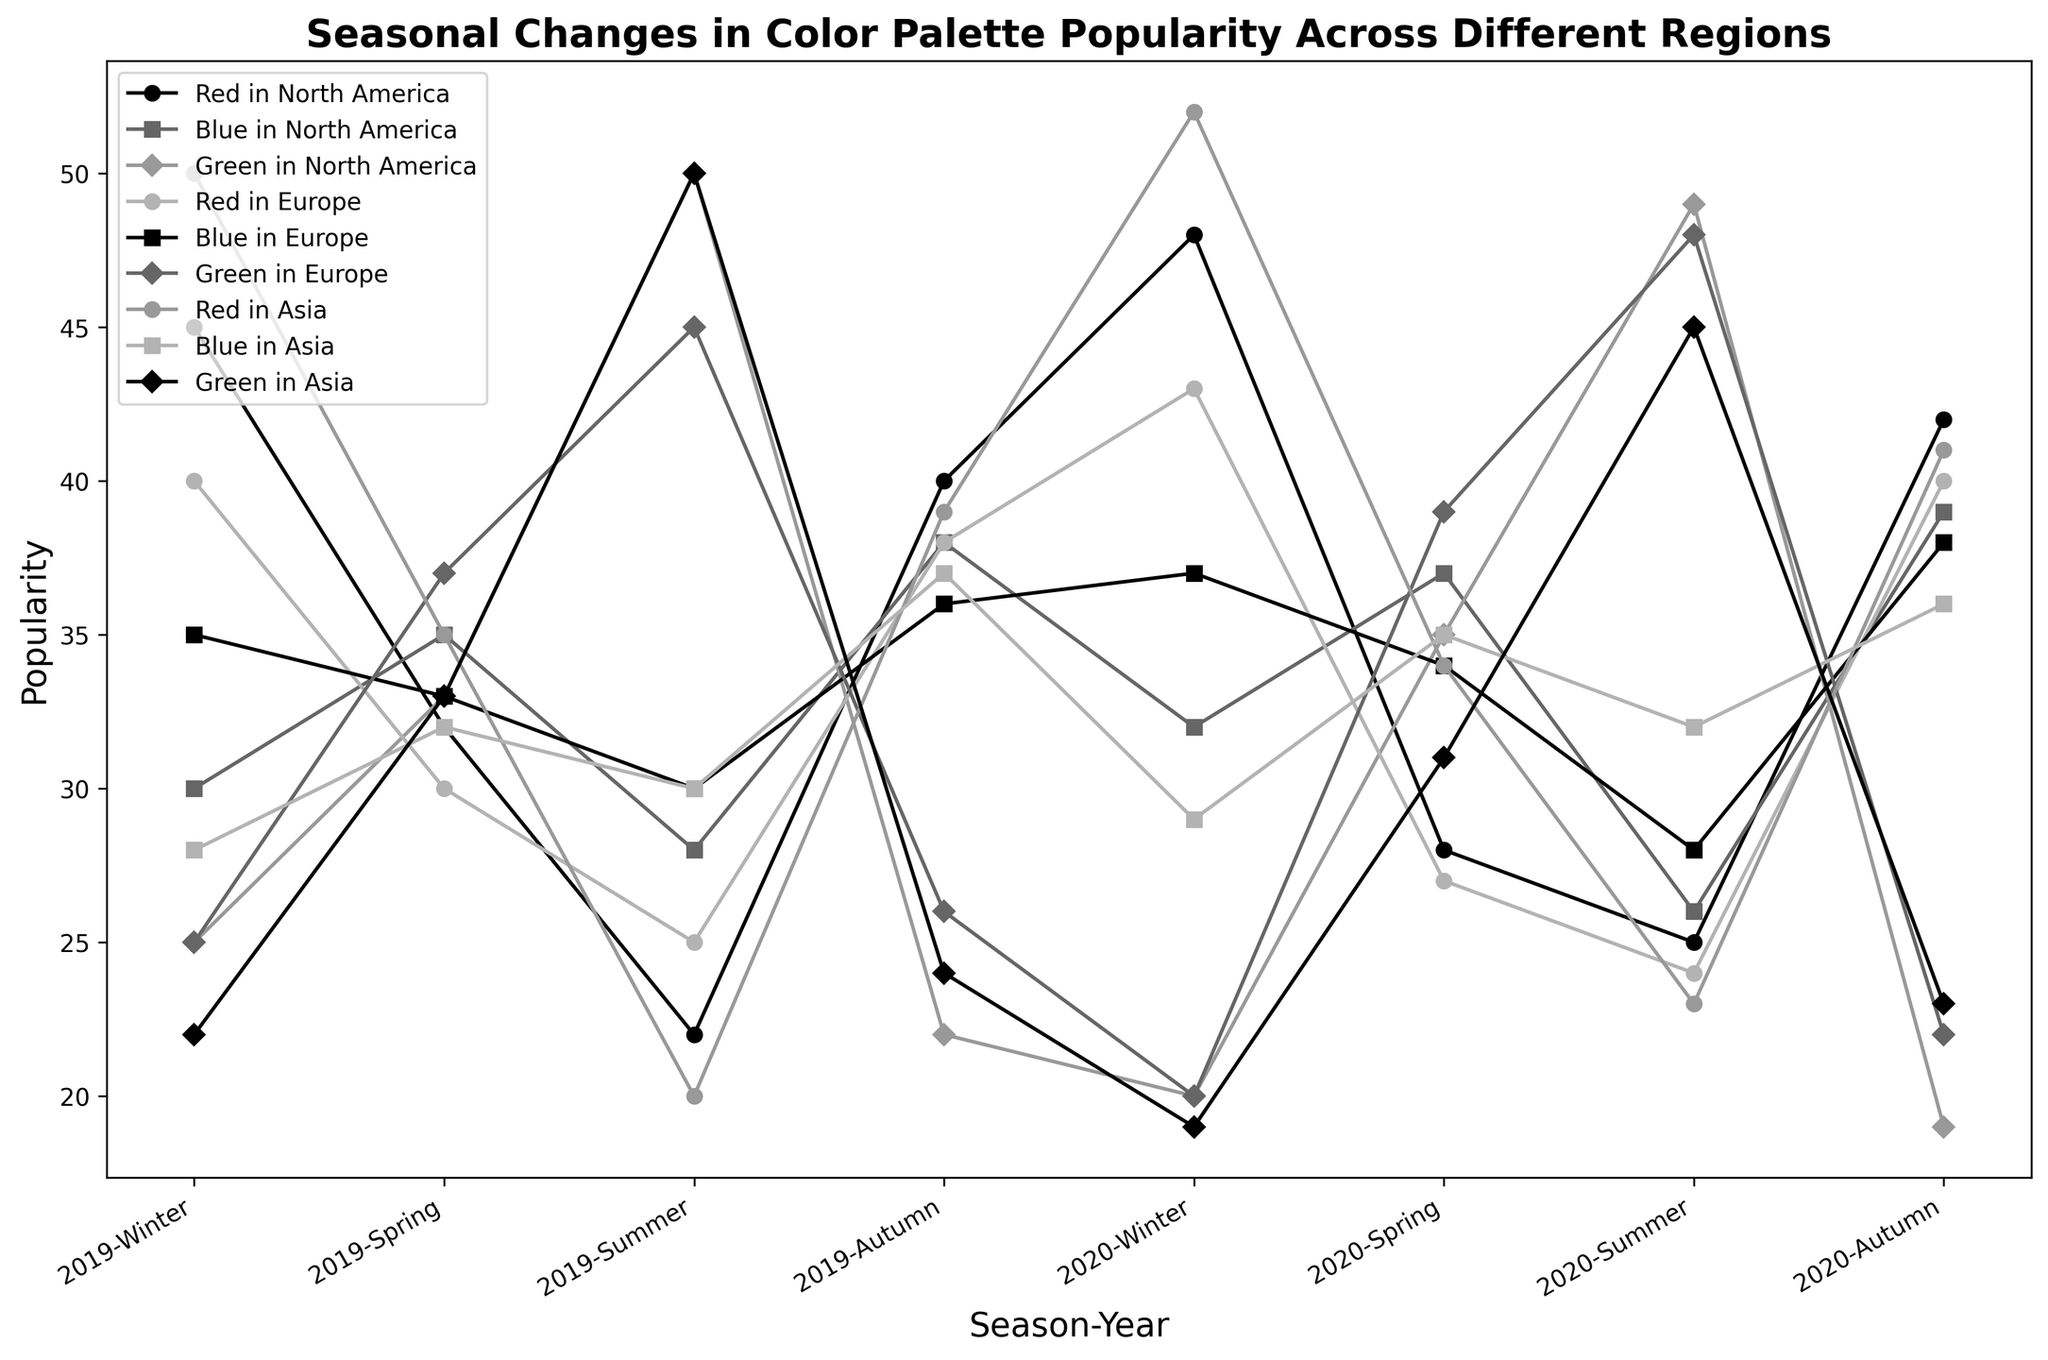What is the trend of red color popularity in North America from Winter 2019 to Autumn 2020? To find the trend, observe the line representing red color in North America across the seasons from Winter 2019 to Autumn 2020. Start by noting the popularity values in Winter 2019 (45), Spring 2019 (32), Summer 2019 (22), Autumn 2019 (40), Winter 2020 (48), Spring 2020 (28), Summer 2020 (25), and Autumn 2020 (42). Look at whether values increase or decrease in each consecutive season.
Answer: The trend is that red's popularity starts high in Winter 2019, dips in Spring and Summer 2019, increases again in Autumn 2019 and Winter 2020, dips slightly in Spring and Summer 2020, then rises again by Autumn 2020 Which region saw the highest popularity of green in Summer 2019? Look at the lines for green color in each region and find the peak points corresponding to Summer 2019. Compare the popularity values of green in North America (50), Europe (45), and Asia (50).
Answer: North America and Asia both saw the highest popularity of green at 50 in Summer 2019 How did the popularity of blue in Europe change between Spring 2019 and Spring 2020? To find the change, compare the popularity values of blue in Europe for Spring 2019 and Spring 2020. The values are 33 for Spring 2019 and 34 for Spring 2020.
Answer: The popularity of blue in Europe increased slightly from Spring 2019 (33) to Spring 2020 (34) In which season and region did red color experience the highest popularity overall? To determine this, identify the highest peak in the red color lines across all seasons and regions. The highest values are North America Winter 2020 (48), Europe Winter 2020 (43), and Asia Winter 2020 (52).
Answer: The highest popularity of red was in Asia during Winter 2020, with a popularity of 52 Which color had the most stable popularity across seasons in Europe from Winter 2019 to Autumn 2020? Examine the fluctuations in popularity values of red, blue, and green in Europe from Winter 2019 to Autumn 2020. Calculate the range of popularity values for each color. Red: fluctuates from 24 to 43, Blue: fluctuates from 28 to 38, Green: fluctuates from 20 to 39.
Answer: Blue had the most stable popularity in Europe, with values ranging from 28 to 38 Compare the popularity trends of blue in North America and Asia. Observe the lines representing blue in North America and Asia across all seasons. Blue in North America starts at 30 (Winter 2019), fluctuates slightly, and ends at 39 (Autumn 2020). Blue in Asia starts at 28 (Winter 2019), fluctuates and ends at 36 (Autumn 2020).
Answer: Both regions show fluctuations, but the overall trend is slightly upward in both North America and Asia What is the average popularity of green in Spring across all regions for the year 2020? To find the average, sum the popularity values of green in Spring 2020 for North America (35), Europe (39), and Asia (31). Then divide by 3. (35 + 39 + 31) / 3 = 105 / 3.
Answer: The average popularity of green in Spring 2020 is 35 Which season saw the biggest increase in popularity for red color in Asia from the previous season? Analyze the changes in red popularity values in Asia from Winter 2019 to Autumn 2020: Winter 2019 (50), Spring 2019 (35), Summer 2019 (20), Autumn 2019 (39), Winter 2020 (52), Spring 2020 (34), Summer 2020 (23), Autumn 2020 (41). The biggest increase is from Autumn 2019 (39) to Winter 2020 (52).
Answer: Winter 2020 saw the biggest increase in popularity for red in Asia How did green's popularity in North America change from Summer to Autumn in both 2019 and 2020? Compare green popularity values in North America from Summer to Autumn in 2019 and 2020. Summer 2019 (50) to Autumn 2019 (22), a decrease of 28. Summer 2020 (49) to Autumn 2020 (19), a decrease of 30.
Answer: Green's popularity decreased both from Summer to Autumn in 2019 and 2020 